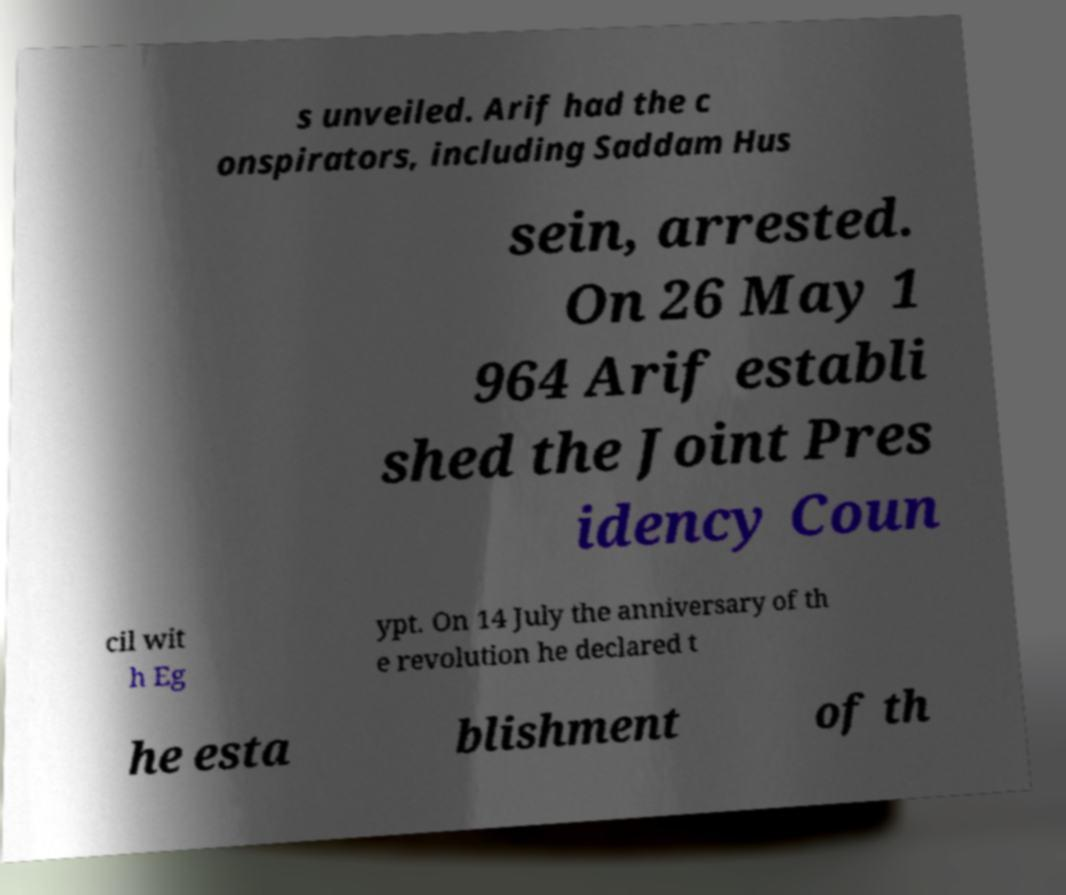Can you read and provide the text displayed in the image?This photo seems to have some interesting text. Can you extract and type it out for me? s unveiled. Arif had the c onspirators, including Saddam Hus sein, arrested. On 26 May 1 964 Arif establi shed the Joint Pres idency Coun cil wit h Eg ypt. On 14 July the anniversary of th e revolution he declared t he esta blishment of th 